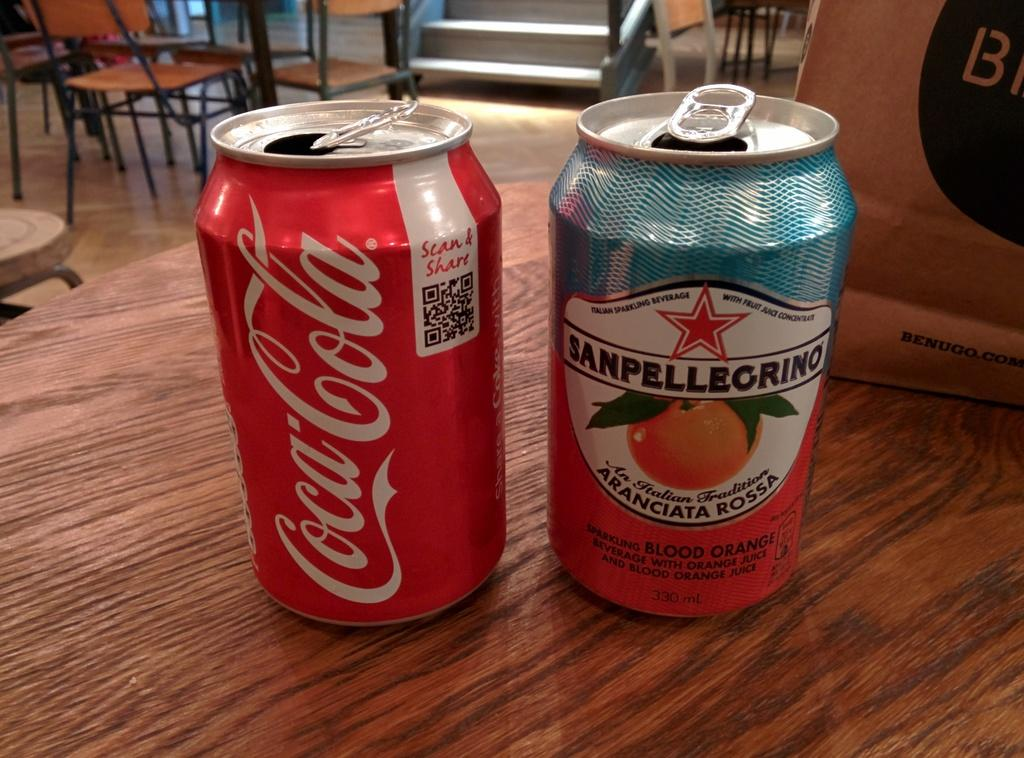<image>
Summarize the visual content of the image. Can of Coca Cola next to another can of fruit juice. 